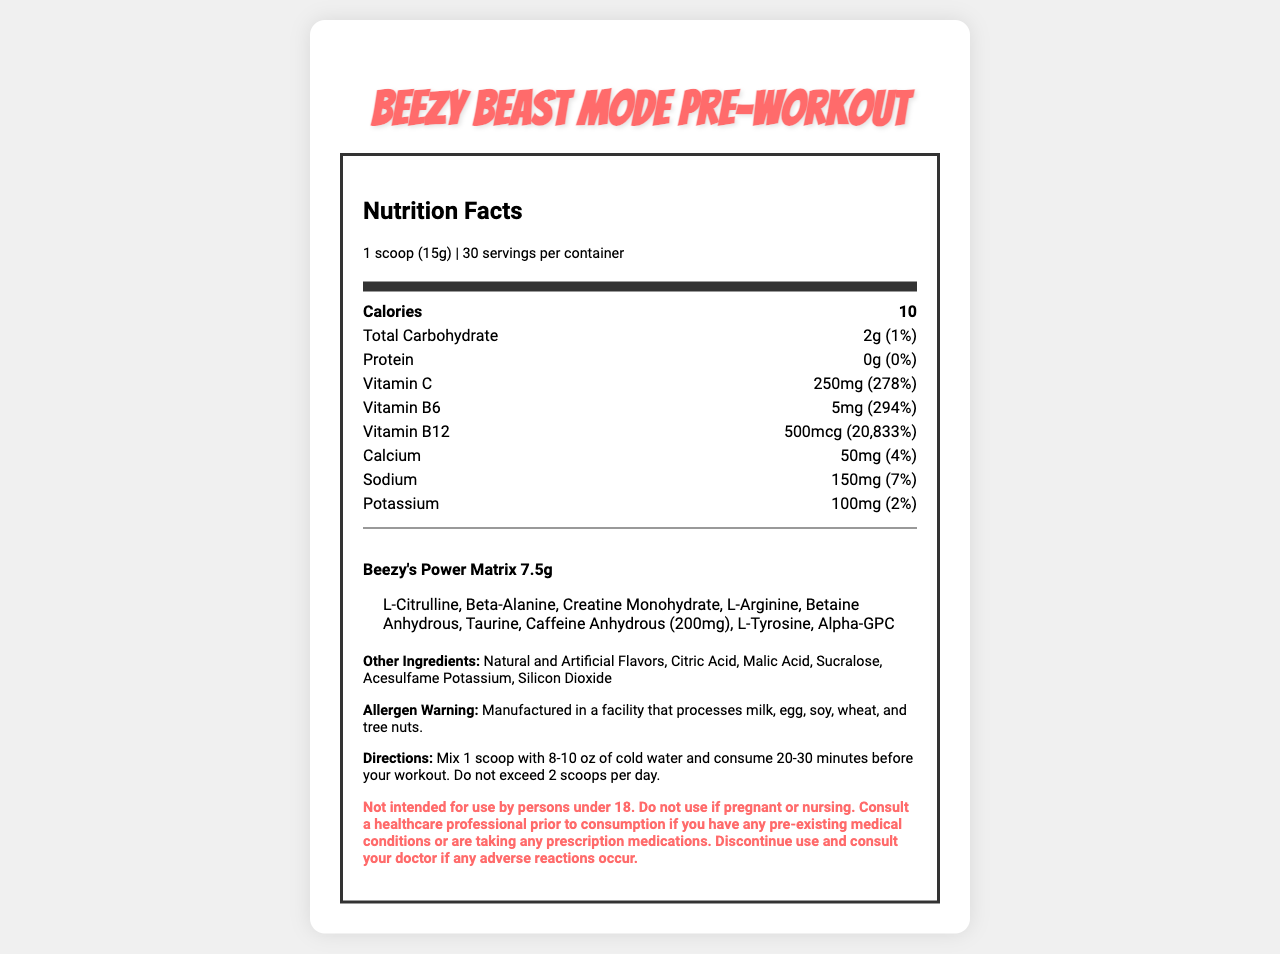what is the serving size of Beezy Beast Mode Pre-Workout? The serving size information is clearly mentioned under the "Nutrition Facts" section.
Answer: 1 scoop (15g) How many servings are in each container of Beezy Beast Mode Pre-Workout? It is mentioned in the "servings per container" information.
Answer: 30 What is the flavor of the Beezy Beast Mode Pre-Workout? The flavor is specified at the bottom of the provided data in the document.
Answer: Beezy's Blue Raspberry Blast How much caffeine is there in one serving of Beezy Beast Mode Pre-Workout? The "Proprietary Blend" includes Caffeine Anhydrous with an amount of 200mg.
Answer: 200mg What is the daily value percentage of Vitamin B12 in Beezy Beast Mode Pre-Workout? The daily value percentage for Vitamin B12 is mentioned directly in the nutrition facts.
Answer: 20,833% Which ingredient in the proprietary blend is listed first? The first ingredient listed under Beezy's Power Matrix is L-Citrulline.
Answer: L-Citrulline How many calories are in each serving of Beezy Beast Mode Pre-Workout? The calorie content is mentioned in the nutrition facts.
Answer: 10 Which of the following is NOT an ingredient in Beezy's Power Matrix? A. L-Citrulline B. Beta-Alanine C. Caffeine Anhydrous D. Whey Protein Whey Protein is not listed in the proprietary blend of Beezy's Power Matrix.
Answer: D. Whey Protein What is the percentage of daily value of Vitamin C in each serving? A. 100% B. 150% C. 278% D. 294% The daily value percentage of Vitamin C is 278%.
Answer: C. 278% Is Beezy Beast Mode Pre-Workout suitable for children under 18 to consume? The document states it is not intended for use by persons under 18.
Answer: No Summarize the key nutritional and supplementary information of Beezy Beast Mode Pre-Workout This summary encapsulates the main components of the document, including serving details, nutritional content, and the proprietary blend specifics.
Answer: Beezy Beast Mode Pre-Workout is a fitness supplement with a serving size of 1 scoop (15g) and contains 30 servings per container. Each serving has 10 calories, 2g of carbohydrates, no protein, significant amounts of Vitamin C, B6, B12, calcium, sodium, and potassium. It also includes a proprietary blend known as Beezy's Power Matrix that contains various performance-enhancing ingredients, including 200mg of caffeine. It is intended for people over 18 and comes in Beezy's Blue Raspberry Blast flavor. What is the manufacturing facility warning for allergens? This warning is specified under the "Allergen Warning" section.
Answer: Manufactured in a facility that processes milk, egg, soy, wheat, and tree nuts. What is the percentage of daily value for protein in Beezy Beast Mode Pre-Workout? The document lists 0g of protein with 0% daily value.
Answer: 0% How many milligrams of sodium are in one serving? Sodium content per serving is mentioned in the document.
Answer: 150mg What is the purpose of consuming this pre-workout supplement 20-30 minutes before a workout? Although it gives directions to consume the supplement 20-30 minutes before a workout, the purpose is implied (likely for enhanced performance), but not explicitly stated.
Answer: The document does not explicitly state the purpose. What is the primary function of proprietary blends in supplements like Beezy Beast Mode Pre-Workout? The document provides the components of Beezy's Power Matrix but does not explain the function or purpose behind the proprietary blend.
Answer: I don't know 